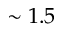Convert formula to latex. <formula><loc_0><loc_0><loc_500><loc_500>\sim 1 . 5</formula> 